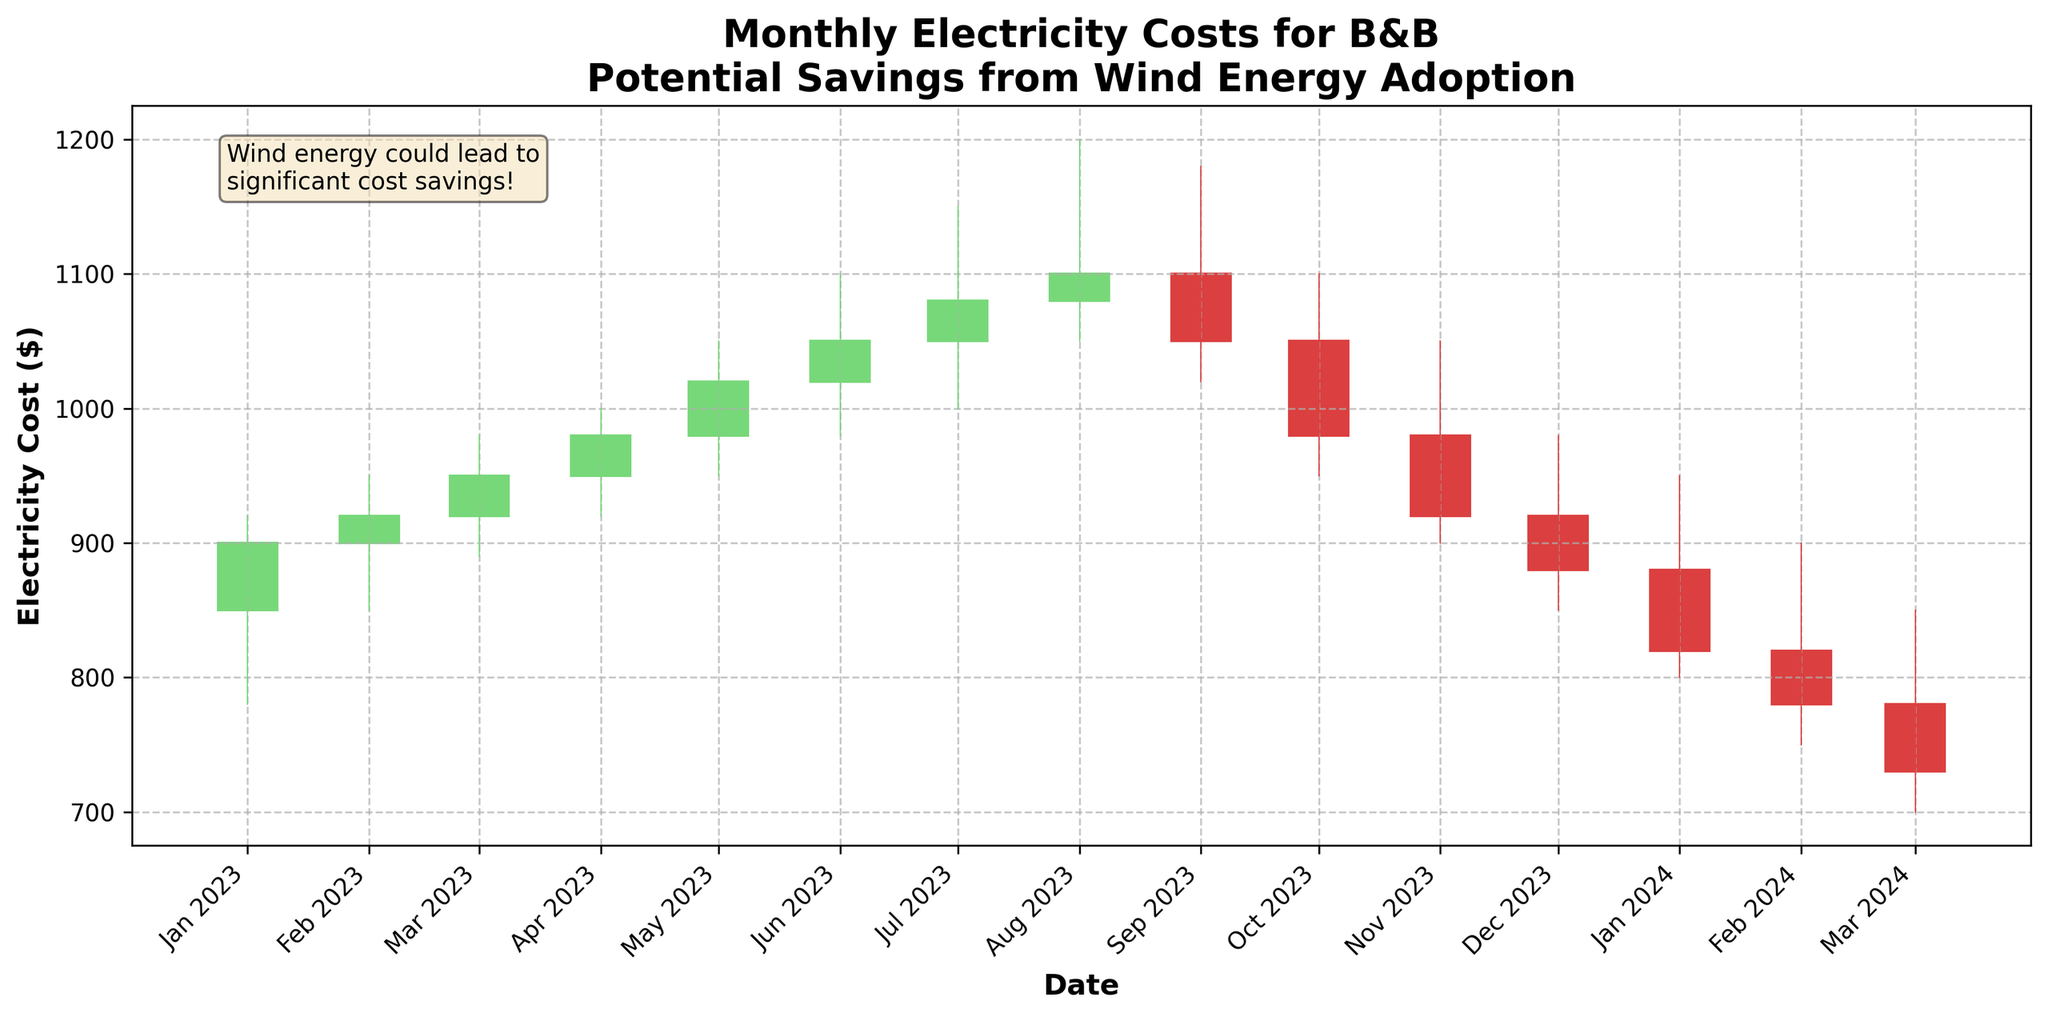What's the title of the chart? The title of the chart is typically located at the top and is the largest text on the plot. It provides a summary of what the chart is depicting.
Answer: Monthly Electricity Costs for B&B Potential Savings from Wind Energy Adoption What is the x-axis representing? The x-axis usually runs horizontally and represents the time period over which the data is plotted. The labels on the x-axis indicate this clearly.
Answer: Date What is the y-axis representing? The y-axis runs vertically and represents the numerical values of the data plotted. The labels on the y-axis indicate that it is showing electricity costs in dollars.
Answer: Electricity Cost ($) Which month had the highest electricity cost? The highest point on the y-axis for each month indicates the highest electricity cost. The tallest green candlestick will represent this. The month with the highest peak in the dataset is July 2023.
Answer: July 2023 How much did the electricity cost decrease from December 2023 to January 2024? To find the decrease, subtract the closing cost of January 2024 from the closing cost of December 2023. So, the decrease is 880 - 820.
Answer: 60 What's the range of electricity costs in May 2023? The range of costs is found by subtracting the lowest point (Low) from the highest point (High) in the month. For May 2023, it's 1050 - 950.
Answer: 100 Which month had the lowest closing electricity cost in 2023? To find the lowest closing cost, you need to look at the lowest point in the closing points for the year 2023. The lowest closing cost in 2023 was in December.
Answer: December 2023 What was the opening cost in February 2023? The opening cost for a month is the value at the start of the candlestick. For February 2023, the opening cost can be directly read off the chart.
Answer: 900 How did the opening cost in January 2024 compare to February 2024? Compare the values at the start of the candlesticks for these months. January 2024 opened at 880, and February 2024 opened at 820; January's opening cost is higher than February’s.
Answer: Higher What was the trend of electricity costs from July 2023 to December 2023? Trend is observed by comparing the general direction of the closing points over the months. From July 2023 to December 2023, the trend was a decrease in the closing costs.
Answer: Decreasing 